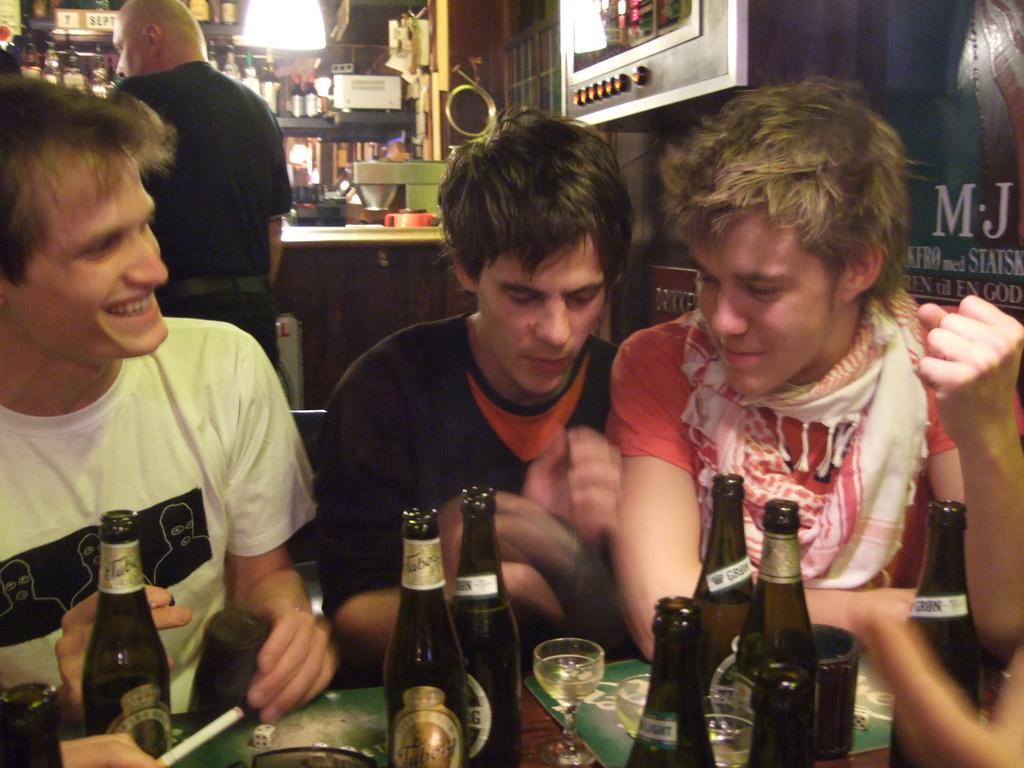In one or two sentences, can you explain what this image depicts? In the image we can see three people were sitting in front of table,on table there is some objects like wine bottles,glasses and cigarette. On the left side person is smiling which we can see on his face. Back of these people one man is standing. Coming to the back ground there was a big shelf with full of wine bottles. 